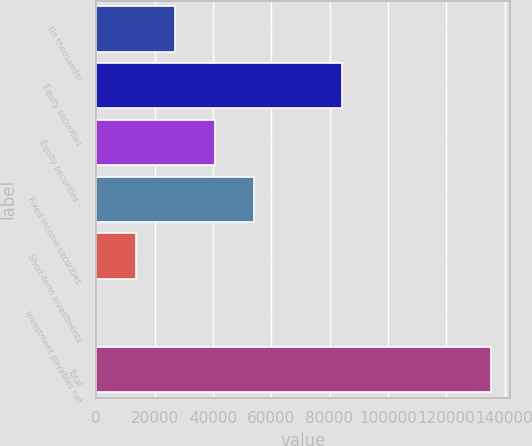Convert chart to OTSL. <chart><loc_0><loc_0><loc_500><loc_500><bar_chart><fcel>(In thousands)<fcel>Equity securities<fcel>Equity securities -<fcel>Fixed income securities<fcel>Short-term investments<fcel>Investment payables net<fcel>Total<nl><fcel>27096.2<fcel>84303<fcel>40615.3<fcel>54134.4<fcel>13577.1<fcel>58<fcel>135249<nl></chart> 